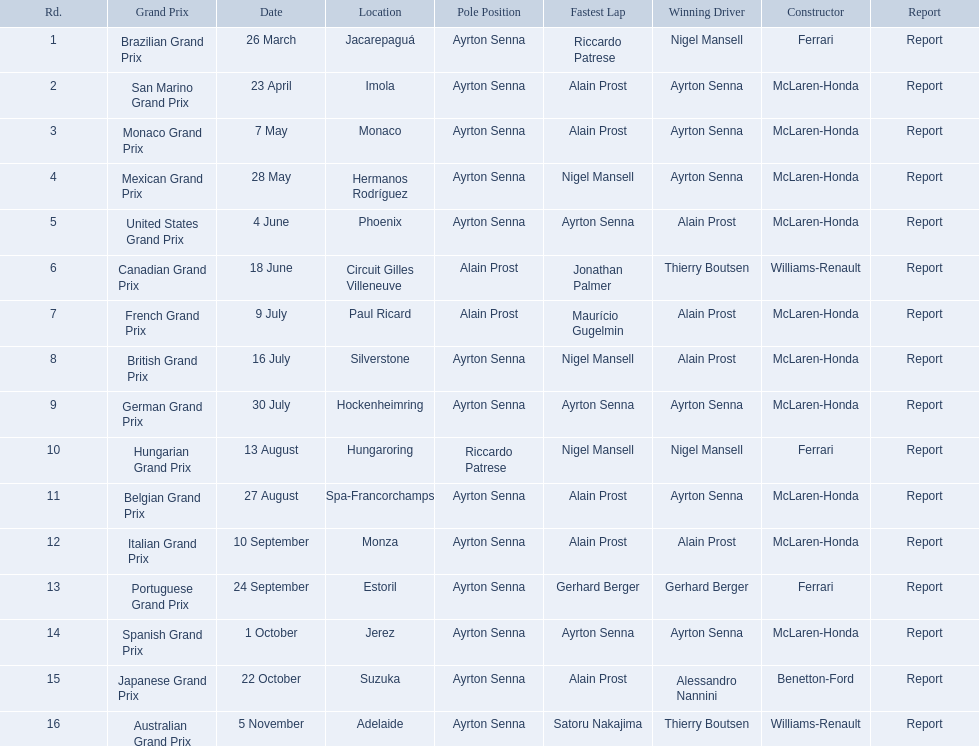Who claimed victory in the spanish grand prix? McLaren-Honda. Who emerged victorious in the italian grand prix? McLaren-Honda. In which grand prix did benneton-ford secure a win? Japanese Grand Prix. 